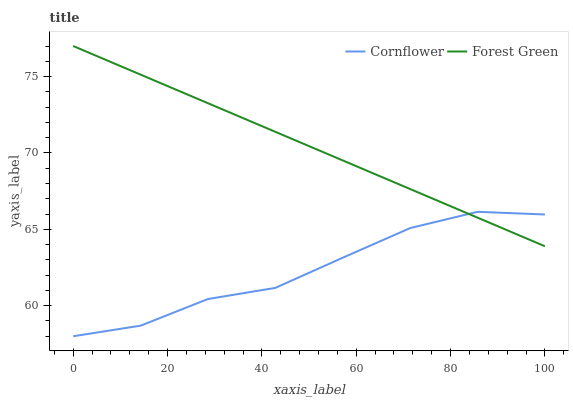Does Cornflower have the minimum area under the curve?
Answer yes or no. Yes. Does Forest Green have the maximum area under the curve?
Answer yes or no. Yes. Does Forest Green have the minimum area under the curve?
Answer yes or no. No. Is Forest Green the smoothest?
Answer yes or no. Yes. Is Cornflower the roughest?
Answer yes or no. Yes. Is Forest Green the roughest?
Answer yes or no. No. Does Cornflower have the lowest value?
Answer yes or no. Yes. Does Forest Green have the lowest value?
Answer yes or no. No. Does Forest Green have the highest value?
Answer yes or no. Yes. Does Forest Green intersect Cornflower?
Answer yes or no. Yes. Is Forest Green less than Cornflower?
Answer yes or no. No. Is Forest Green greater than Cornflower?
Answer yes or no. No. 